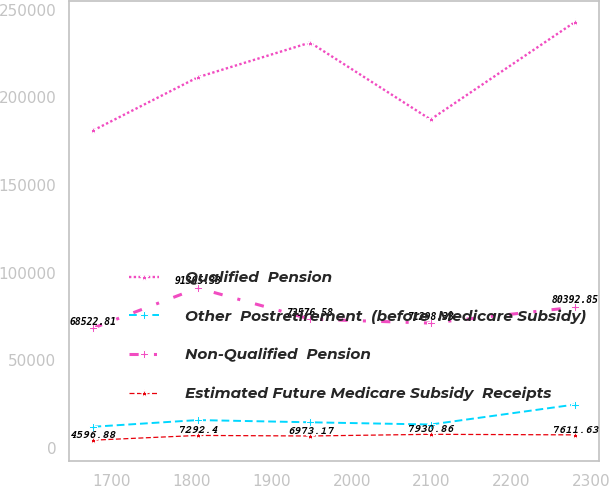Convert chart to OTSL. <chart><loc_0><loc_0><loc_500><loc_500><line_chart><ecel><fcel>Qualified  Pension<fcel>Other  Postretirement  (before  Medicare Subsidy)<fcel>Non-Qualified  Pension<fcel>Estimated Future Medicare Subsidy  Receipts<nl><fcel>1676.73<fcel>181171<fcel>12246.3<fcel>68522.8<fcel>4596.88<nl><fcel>1807.51<fcel>211432<fcel>16046.8<fcel>91305.3<fcel>7292.4<nl><fcel>1948.03<fcel>231191<fcel>14780<fcel>73576.6<fcel>6973.17<nl><fcel>2098.79<fcel>187350<fcel>13513.1<fcel>71298.3<fcel>7930.86<nl><fcel>2279.7<fcel>242959<fcel>24914.4<fcel>80392.9<fcel>7611.63<nl></chart> 